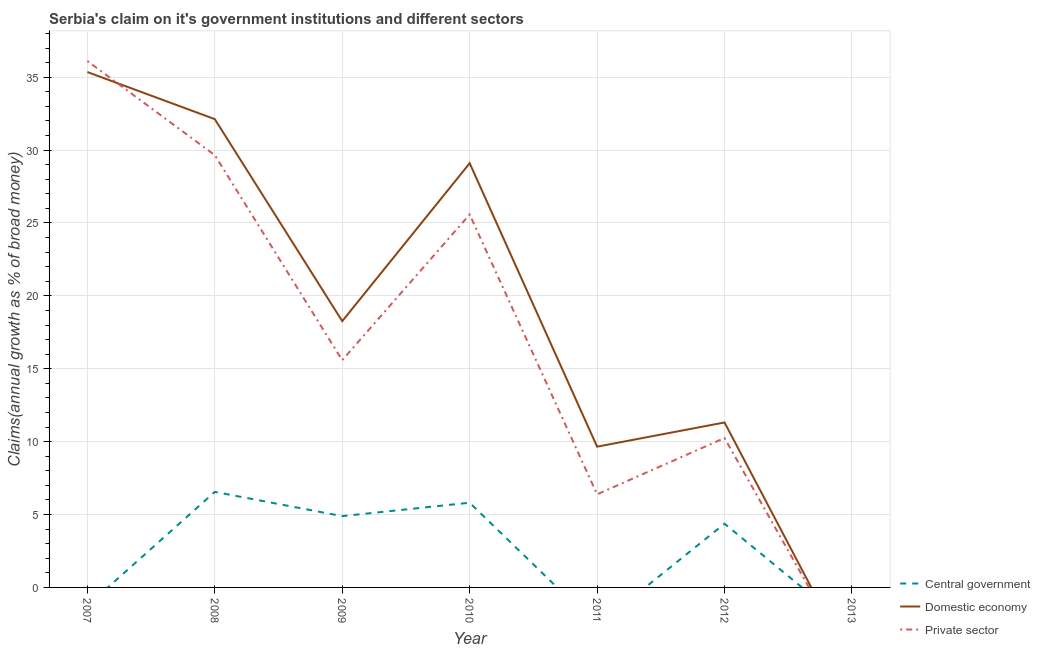How many different coloured lines are there?
Ensure brevity in your answer.  3. Does the line corresponding to percentage of claim on the private sector intersect with the line corresponding to percentage of claim on the central government?
Provide a succinct answer. Yes. What is the percentage of claim on the domestic economy in 2011?
Your answer should be compact. 9.66. Across all years, what is the maximum percentage of claim on the private sector?
Provide a succinct answer. 36.11. What is the total percentage of claim on the private sector in the graph?
Your answer should be very brief. 123.57. What is the difference between the percentage of claim on the central government in 2009 and that in 2012?
Give a very brief answer. 0.52. What is the difference between the percentage of claim on the central government in 2012 and the percentage of claim on the domestic economy in 2010?
Your answer should be very brief. -24.73. What is the average percentage of claim on the central government per year?
Your response must be concise. 3.09. In the year 2012, what is the difference between the percentage of claim on the private sector and percentage of claim on the central government?
Your answer should be compact. 5.88. In how many years, is the percentage of claim on the private sector greater than 9 %?
Offer a very short reply. 5. What is the ratio of the percentage of claim on the domestic economy in 2007 to that in 2008?
Provide a succinct answer. 1.1. What is the difference between the highest and the second highest percentage of claim on the private sector?
Offer a very short reply. 6.46. What is the difference between the highest and the lowest percentage of claim on the central government?
Your answer should be very brief. 6.55. Is the sum of the percentage of claim on the private sector in 2007 and 2010 greater than the maximum percentage of claim on the central government across all years?
Provide a short and direct response. Yes. Does the percentage of claim on the domestic economy monotonically increase over the years?
Give a very brief answer. No. How many years are there in the graph?
Provide a short and direct response. 7. Does the graph contain grids?
Your answer should be compact. Yes. What is the title of the graph?
Provide a succinct answer. Serbia's claim on it's government institutions and different sectors. Does "Solid fuel" appear as one of the legend labels in the graph?
Your answer should be very brief. No. What is the label or title of the X-axis?
Offer a very short reply. Year. What is the label or title of the Y-axis?
Offer a very short reply. Claims(annual growth as % of broad money). What is the Claims(annual growth as % of broad money) in Central government in 2007?
Your response must be concise. 0. What is the Claims(annual growth as % of broad money) in Domestic economy in 2007?
Offer a very short reply. 35.36. What is the Claims(annual growth as % of broad money) in Private sector in 2007?
Your answer should be compact. 36.11. What is the Claims(annual growth as % of broad money) of Central government in 2008?
Give a very brief answer. 6.55. What is the Claims(annual growth as % of broad money) of Domestic economy in 2008?
Your answer should be very brief. 32.12. What is the Claims(annual growth as % of broad money) of Private sector in 2008?
Keep it short and to the point. 29.65. What is the Claims(annual growth as % of broad money) of Central government in 2009?
Your answer should be compact. 4.89. What is the Claims(annual growth as % of broad money) in Domestic economy in 2009?
Keep it short and to the point. 18.27. What is the Claims(annual growth as % of broad money) of Private sector in 2009?
Provide a succinct answer. 15.59. What is the Claims(annual growth as % of broad money) in Central government in 2010?
Offer a very short reply. 5.81. What is the Claims(annual growth as % of broad money) in Domestic economy in 2010?
Keep it short and to the point. 29.1. What is the Claims(annual growth as % of broad money) in Private sector in 2010?
Offer a very short reply. 25.58. What is the Claims(annual growth as % of broad money) in Central government in 2011?
Make the answer very short. 0. What is the Claims(annual growth as % of broad money) of Domestic economy in 2011?
Provide a succinct answer. 9.66. What is the Claims(annual growth as % of broad money) of Private sector in 2011?
Make the answer very short. 6.39. What is the Claims(annual growth as % of broad money) in Central government in 2012?
Provide a short and direct response. 4.37. What is the Claims(annual growth as % of broad money) of Domestic economy in 2012?
Give a very brief answer. 11.32. What is the Claims(annual growth as % of broad money) of Private sector in 2012?
Provide a short and direct response. 10.25. What is the Claims(annual growth as % of broad money) of Private sector in 2013?
Offer a very short reply. 0. Across all years, what is the maximum Claims(annual growth as % of broad money) in Central government?
Your answer should be compact. 6.55. Across all years, what is the maximum Claims(annual growth as % of broad money) of Domestic economy?
Keep it short and to the point. 35.36. Across all years, what is the maximum Claims(annual growth as % of broad money) in Private sector?
Your answer should be compact. 36.11. Across all years, what is the minimum Claims(annual growth as % of broad money) of Central government?
Your answer should be compact. 0. Across all years, what is the minimum Claims(annual growth as % of broad money) of Private sector?
Your response must be concise. 0. What is the total Claims(annual growth as % of broad money) of Central government in the graph?
Keep it short and to the point. 21.63. What is the total Claims(annual growth as % of broad money) of Domestic economy in the graph?
Offer a very short reply. 135.82. What is the total Claims(annual growth as % of broad money) in Private sector in the graph?
Offer a terse response. 123.57. What is the difference between the Claims(annual growth as % of broad money) in Domestic economy in 2007 and that in 2008?
Provide a succinct answer. 3.23. What is the difference between the Claims(annual growth as % of broad money) of Private sector in 2007 and that in 2008?
Provide a succinct answer. 6.46. What is the difference between the Claims(annual growth as % of broad money) in Domestic economy in 2007 and that in 2009?
Offer a very short reply. 17.09. What is the difference between the Claims(annual growth as % of broad money) in Private sector in 2007 and that in 2009?
Your answer should be compact. 20.52. What is the difference between the Claims(annual growth as % of broad money) of Domestic economy in 2007 and that in 2010?
Your answer should be compact. 6.25. What is the difference between the Claims(annual growth as % of broad money) in Private sector in 2007 and that in 2010?
Provide a short and direct response. 10.53. What is the difference between the Claims(annual growth as % of broad money) of Domestic economy in 2007 and that in 2011?
Make the answer very short. 25.7. What is the difference between the Claims(annual growth as % of broad money) of Private sector in 2007 and that in 2011?
Offer a very short reply. 29.73. What is the difference between the Claims(annual growth as % of broad money) in Domestic economy in 2007 and that in 2012?
Give a very brief answer. 24.04. What is the difference between the Claims(annual growth as % of broad money) in Private sector in 2007 and that in 2012?
Your response must be concise. 25.86. What is the difference between the Claims(annual growth as % of broad money) of Central government in 2008 and that in 2009?
Your answer should be compact. 1.66. What is the difference between the Claims(annual growth as % of broad money) in Domestic economy in 2008 and that in 2009?
Offer a terse response. 13.86. What is the difference between the Claims(annual growth as % of broad money) of Private sector in 2008 and that in 2009?
Your response must be concise. 14.07. What is the difference between the Claims(annual growth as % of broad money) in Central government in 2008 and that in 2010?
Your response must be concise. 0.74. What is the difference between the Claims(annual growth as % of broad money) in Domestic economy in 2008 and that in 2010?
Provide a short and direct response. 3.02. What is the difference between the Claims(annual growth as % of broad money) in Private sector in 2008 and that in 2010?
Offer a very short reply. 4.07. What is the difference between the Claims(annual growth as % of broad money) in Domestic economy in 2008 and that in 2011?
Provide a succinct answer. 22.47. What is the difference between the Claims(annual growth as % of broad money) of Private sector in 2008 and that in 2011?
Offer a very short reply. 23.27. What is the difference between the Claims(annual growth as % of broad money) of Central government in 2008 and that in 2012?
Your response must be concise. 2.18. What is the difference between the Claims(annual growth as % of broad money) in Domestic economy in 2008 and that in 2012?
Provide a short and direct response. 20.81. What is the difference between the Claims(annual growth as % of broad money) in Private sector in 2008 and that in 2012?
Make the answer very short. 19.4. What is the difference between the Claims(annual growth as % of broad money) in Central government in 2009 and that in 2010?
Make the answer very short. -0.92. What is the difference between the Claims(annual growth as % of broad money) of Domestic economy in 2009 and that in 2010?
Your answer should be very brief. -10.83. What is the difference between the Claims(annual growth as % of broad money) in Private sector in 2009 and that in 2010?
Your answer should be compact. -9.99. What is the difference between the Claims(annual growth as % of broad money) in Domestic economy in 2009 and that in 2011?
Give a very brief answer. 8.61. What is the difference between the Claims(annual growth as % of broad money) in Private sector in 2009 and that in 2011?
Your response must be concise. 9.2. What is the difference between the Claims(annual growth as % of broad money) in Central government in 2009 and that in 2012?
Ensure brevity in your answer.  0.52. What is the difference between the Claims(annual growth as % of broad money) in Domestic economy in 2009 and that in 2012?
Offer a very short reply. 6.95. What is the difference between the Claims(annual growth as % of broad money) in Private sector in 2009 and that in 2012?
Your answer should be compact. 5.34. What is the difference between the Claims(annual growth as % of broad money) in Domestic economy in 2010 and that in 2011?
Your answer should be very brief. 19.44. What is the difference between the Claims(annual growth as % of broad money) of Private sector in 2010 and that in 2011?
Ensure brevity in your answer.  19.19. What is the difference between the Claims(annual growth as % of broad money) of Central government in 2010 and that in 2012?
Offer a very short reply. 1.44. What is the difference between the Claims(annual growth as % of broad money) of Domestic economy in 2010 and that in 2012?
Your response must be concise. 17.79. What is the difference between the Claims(annual growth as % of broad money) in Private sector in 2010 and that in 2012?
Make the answer very short. 15.33. What is the difference between the Claims(annual growth as % of broad money) in Domestic economy in 2011 and that in 2012?
Provide a succinct answer. -1.66. What is the difference between the Claims(annual growth as % of broad money) of Private sector in 2011 and that in 2012?
Provide a short and direct response. -3.86. What is the difference between the Claims(annual growth as % of broad money) in Domestic economy in 2007 and the Claims(annual growth as % of broad money) in Private sector in 2008?
Keep it short and to the point. 5.7. What is the difference between the Claims(annual growth as % of broad money) in Domestic economy in 2007 and the Claims(annual growth as % of broad money) in Private sector in 2009?
Your response must be concise. 19.77. What is the difference between the Claims(annual growth as % of broad money) in Domestic economy in 2007 and the Claims(annual growth as % of broad money) in Private sector in 2010?
Ensure brevity in your answer.  9.77. What is the difference between the Claims(annual growth as % of broad money) in Domestic economy in 2007 and the Claims(annual growth as % of broad money) in Private sector in 2011?
Keep it short and to the point. 28.97. What is the difference between the Claims(annual growth as % of broad money) in Domestic economy in 2007 and the Claims(annual growth as % of broad money) in Private sector in 2012?
Offer a terse response. 25.11. What is the difference between the Claims(annual growth as % of broad money) of Central government in 2008 and the Claims(annual growth as % of broad money) of Domestic economy in 2009?
Keep it short and to the point. -11.71. What is the difference between the Claims(annual growth as % of broad money) in Central government in 2008 and the Claims(annual growth as % of broad money) in Private sector in 2009?
Your answer should be very brief. -9.03. What is the difference between the Claims(annual growth as % of broad money) in Domestic economy in 2008 and the Claims(annual growth as % of broad money) in Private sector in 2009?
Give a very brief answer. 16.53. What is the difference between the Claims(annual growth as % of broad money) of Central government in 2008 and the Claims(annual growth as % of broad money) of Domestic economy in 2010?
Your answer should be compact. -22.55. What is the difference between the Claims(annual growth as % of broad money) of Central government in 2008 and the Claims(annual growth as % of broad money) of Private sector in 2010?
Make the answer very short. -19.03. What is the difference between the Claims(annual growth as % of broad money) of Domestic economy in 2008 and the Claims(annual growth as % of broad money) of Private sector in 2010?
Offer a terse response. 6.54. What is the difference between the Claims(annual growth as % of broad money) in Central government in 2008 and the Claims(annual growth as % of broad money) in Domestic economy in 2011?
Your response must be concise. -3.1. What is the difference between the Claims(annual growth as % of broad money) in Central government in 2008 and the Claims(annual growth as % of broad money) in Private sector in 2011?
Provide a short and direct response. 0.17. What is the difference between the Claims(annual growth as % of broad money) of Domestic economy in 2008 and the Claims(annual growth as % of broad money) of Private sector in 2011?
Your answer should be very brief. 25.74. What is the difference between the Claims(annual growth as % of broad money) in Central government in 2008 and the Claims(annual growth as % of broad money) in Domestic economy in 2012?
Offer a very short reply. -4.76. What is the difference between the Claims(annual growth as % of broad money) of Central government in 2008 and the Claims(annual growth as % of broad money) of Private sector in 2012?
Your answer should be very brief. -3.7. What is the difference between the Claims(annual growth as % of broad money) in Domestic economy in 2008 and the Claims(annual growth as % of broad money) in Private sector in 2012?
Offer a very short reply. 21.87. What is the difference between the Claims(annual growth as % of broad money) of Central government in 2009 and the Claims(annual growth as % of broad money) of Domestic economy in 2010?
Offer a terse response. -24.21. What is the difference between the Claims(annual growth as % of broad money) of Central government in 2009 and the Claims(annual growth as % of broad money) of Private sector in 2010?
Your answer should be compact. -20.69. What is the difference between the Claims(annual growth as % of broad money) in Domestic economy in 2009 and the Claims(annual growth as % of broad money) in Private sector in 2010?
Your answer should be very brief. -7.31. What is the difference between the Claims(annual growth as % of broad money) of Central government in 2009 and the Claims(annual growth as % of broad money) of Domestic economy in 2011?
Offer a very short reply. -4.77. What is the difference between the Claims(annual growth as % of broad money) in Central government in 2009 and the Claims(annual growth as % of broad money) in Private sector in 2011?
Provide a succinct answer. -1.5. What is the difference between the Claims(annual growth as % of broad money) of Domestic economy in 2009 and the Claims(annual growth as % of broad money) of Private sector in 2011?
Make the answer very short. 11.88. What is the difference between the Claims(annual growth as % of broad money) in Central government in 2009 and the Claims(annual growth as % of broad money) in Domestic economy in 2012?
Provide a short and direct response. -6.43. What is the difference between the Claims(annual growth as % of broad money) in Central government in 2009 and the Claims(annual growth as % of broad money) in Private sector in 2012?
Ensure brevity in your answer.  -5.36. What is the difference between the Claims(annual growth as % of broad money) in Domestic economy in 2009 and the Claims(annual growth as % of broad money) in Private sector in 2012?
Ensure brevity in your answer.  8.02. What is the difference between the Claims(annual growth as % of broad money) of Central government in 2010 and the Claims(annual growth as % of broad money) of Domestic economy in 2011?
Provide a succinct answer. -3.84. What is the difference between the Claims(annual growth as % of broad money) in Central government in 2010 and the Claims(annual growth as % of broad money) in Private sector in 2011?
Keep it short and to the point. -0.57. What is the difference between the Claims(annual growth as % of broad money) of Domestic economy in 2010 and the Claims(annual growth as % of broad money) of Private sector in 2011?
Your answer should be compact. 22.71. What is the difference between the Claims(annual growth as % of broad money) of Central government in 2010 and the Claims(annual growth as % of broad money) of Domestic economy in 2012?
Offer a very short reply. -5.5. What is the difference between the Claims(annual growth as % of broad money) in Central government in 2010 and the Claims(annual growth as % of broad money) in Private sector in 2012?
Make the answer very short. -4.44. What is the difference between the Claims(annual growth as % of broad money) in Domestic economy in 2010 and the Claims(annual growth as % of broad money) in Private sector in 2012?
Provide a short and direct response. 18.85. What is the difference between the Claims(annual growth as % of broad money) in Domestic economy in 2011 and the Claims(annual growth as % of broad money) in Private sector in 2012?
Keep it short and to the point. -0.59. What is the average Claims(annual growth as % of broad money) of Central government per year?
Ensure brevity in your answer.  3.09. What is the average Claims(annual growth as % of broad money) of Domestic economy per year?
Make the answer very short. 19.4. What is the average Claims(annual growth as % of broad money) of Private sector per year?
Your response must be concise. 17.65. In the year 2007, what is the difference between the Claims(annual growth as % of broad money) in Domestic economy and Claims(annual growth as % of broad money) in Private sector?
Your answer should be compact. -0.76. In the year 2008, what is the difference between the Claims(annual growth as % of broad money) in Central government and Claims(annual growth as % of broad money) in Domestic economy?
Keep it short and to the point. -25.57. In the year 2008, what is the difference between the Claims(annual growth as % of broad money) of Central government and Claims(annual growth as % of broad money) of Private sector?
Offer a very short reply. -23.1. In the year 2008, what is the difference between the Claims(annual growth as % of broad money) in Domestic economy and Claims(annual growth as % of broad money) in Private sector?
Keep it short and to the point. 2.47. In the year 2009, what is the difference between the Claims(annual growth as % of broad money) in Central government and Claims(annual growth as % of broad money) in Domestic economy?
Keep it short and to the point. -13.38. In the year 2009, what is the difference between the Claims(annual growth as % of broad money) in Central government and Claims(annual growth as % of broad money) in Private sector?
Offer a terse response. -10.7. In the year 2009, what is the difference between the Claims(annual growth as % of broad money) in Domestic economy and Claims(annual growth as % of broad money) in Private sector?
Keep it short and to the point. 2.68. In the year 2010, what is the difference between the Claims(annual growth as % of broad money) of Central government and Claims(annual growth as % of broad money) of Domestic economy?
Offer a terse response. -23.29. In the year 2010, what is the difference between the Claims(annual growth as % of broad money) of Central government and Claims(annual growth as % of broad money) of Private sector?
Your response must be concise. -19.77. In the year 2010, what is the difference between the Claims(annual growth as % of broad money) in Domestic economy and Claims(annual growth as % of broad money) in Private sector?
Your response must be concise. 3.52. In the year 2011, what is the difference between the Claims(annual growth as % of broad money) of Domestic economy and Claims(annual growth as % of broad money) of Private sector?
Offer a terse response. 3.27. In the year 2012, what is the difference between the Claims(annual growth as % of broad money) of Central government and Claims(annual growth as % of broad money) of Domestic economy?
Your response must be concise. -6.95. In the year 2012, what is the difference between the Claims(annual growth as % of broad money) in Central government and Claims(annual growth as % of broad money) in Private sector?
Your response must be concise. -5.88. In the year 2012, what is the difference between the Claims(annual growth as % of broad money) of Domestic economy and Claims(annual growth as % of broad money) of Private sector?
Make the answer very short. 1.07. What is the ratio of the Claims(annual growth as % of broad money) of Domestic economy in 2007 to that in 2008?
Give a very brief answer. 1.1. What is the ratio of the Claims(annual growth as % of broad money) of Private sector in 2007 to that in 2008?
Offer a very short reply. 1.22. What is the ratio of the Claims(annual growth as % of broad money) in Domestic economy in 2007 to that in 2009?
Your response must be concise. 1.94. What is the ratio of the Claims(annual growth as % of broad money) of Private sector in 2007 to that in 2009?
Offer a terse response. 2.32. What is the ratio of the Claims(annual growth as % of broad money) in Domestic economy in 2007 to that in 2010?
Provide a short and direct response. 1.21. What is the ratio of the Claims(annual growth as % of broad money) of Private sector in 2007 to that in 2010?
Offer a terse response. 1.41. What is the ratio of the Claims(annual growth as % of broad money) of Domestic economy in 2007 to that in 2011?
Your answer should be compact. 3.66. What is the ratio of the Claims(annual growth as % of broad money) in Private sector in 2007 to that in 2011?
Your response must be concise. 5.65. What is the ratio of the Claims(annual growth as % of broad money) of Domestic economy in 2007 to that in 2012?
Your answer should be very brief. 3.12. What is the ratio of the Claims(annual growth as % of broad money) in Private sector in 2007 to that in 2012?
Keep it short and to the point. 3.52. What is the ratio of the Claims(annual growth as % of broad money) in Central government in 2008 to that in 2009?
Your answer should be compact. 1.34. What is the ratio of the Claims(annual growth as % of broad money) of Domestic economy in 2008 to that in 2009?
Provide a succinct answer. 1.76. What is the ratio of the Claims(annual growth as % of broad money) of Private sector in 2008 to that in 2009?
Ensure brevity in your answer.  1.9. What is the ratio of the Claims(annual growth as % of broad money) of Central government in 2008 to that in 2010?
Provide a short and direct response. 1.13. What is the ratio of the Claims(annual growth as % of broad money) in Domestic economy in 2008 to that in 2010?
Provide a short and direct response. 1.1. What is the ratio of the Claims(annual growth as % of broad money) of Private sector in 2008 to that in 2010?
Provide a succinct answer. 1.16. What is the ratio of the Claims(annual growth as % of broad money) in Domestic economy in 2008 to that in 2011?
Offer a very short reply. 3.33. What is the ratio of the Claims(annual growth as % of broad money) in Private sector in 2008 to that in 2011?
Offer a terse response. 4.64. What is the ratio of the Claims(annual growth as % of broad money) of Domestic economy in 2008 to that in 2012?
Give a very brief answer. 2.84. What is the ratio of the Claims(annual growth as % of broad money) of Private sector in 2008 to that in 2012?
Make the answer very short. 2.89. What is the ratio of the Claims(annual growth as % of broad money) of Central government in 2009 to that in 2010?
Your answer should be very brief. 0.84. What is the ratio of the Claims(annual growth as % of broad money) in Domestic economy in 2009 to that in 2010?
Offer a very short reply. 0.63. What is the ratio of the Claims(annual growth as % of broad money) of Private sector in 2009 to that in 2010?
Ensure brevity in your answer.  0.61. What is the ratio of the Claims(annual growth as % of broad money) of Domestic economy in 2009 to that in 2011?
Give a very brief answer. 1.89. What is the ratio of the Claims(annual growth as % of broad money) of Private sector in 2009 to that in 2011?
Your answer should be compact. 2.44. What is the ratio of the Claims(annual growth as % of broad money) in Central government in 2009 to that in 2012?
Your answer should be compact. 1.12. What is the ratio of the Claims(annual growth as % of broad money) in Domestic economy in 2009 to that in 2012?
Ensure brevity in your answer.  1.61. What is the ratio of the Claims(annual growth as % of broad money) of Private sector in 2009 to that in 2012?
Offer a terse response. 1.52. What is the ratio of the Claims(annual growth as % of broad money) of Domestic economy in 2010 to that in 2011?
Provide a short and direct response. 3.01. What is the ratio of the Claims(annual growth as % of broad money) in Private sector in 2010 to that in 2011?
Your answer should be compact. 4.01. What is the ratio of the Claims(annual growth as % of broad money) in Central government in 2010 to that in 2012?
Make the answer very short. 1.33. What is the ratio of the Claims(annual growth as % of broad money) of Domestic economy in 2010 to that in 2012?
Your response must be concise. 2.57. What is the ratio of the Claims(annual growth as % of broad money) of Private sector in 2010 to that in 2012?
Offer a very short reply. 2.5. What is the ratio of the Claims(annual growth as % of broad money) of Domestic economy in 2011 to that in 2012?
Give a very brief answer. 0.85. What is the ratio of the Claims(annual growth as % of broad money) in Private sector in 2011 to that in 2012?
Give a very brief answer. 0.62. What is the difference between the highest and the second highest Claims(annual growth as % of broad money) in Central government?
Your response must be concise. 0.74. What is the difference between the highest and the second highest Claims(annual growth as % of broad money) in Domestic economy?
Your answer should be very brief. 3.23. What is the difference between the highest and the second highest Claims(annual growth as % of broad money) in Private sector?
Give a very brief answer. 6.46. What is the difference between the highest and the lowest Claims(annual growth as % of broad money) in Central government?
Your answer should be compact. 6.55. What is the difference between the highest and the lowest Claims(annual growth as % of broad money) in Domestic economy?
Give a very brief answer. 35.36. What is the difference between the highest and the lowest Claims(annual growth as % of broad money) of Private sector?
Provide a short and direct response. 36.11. 